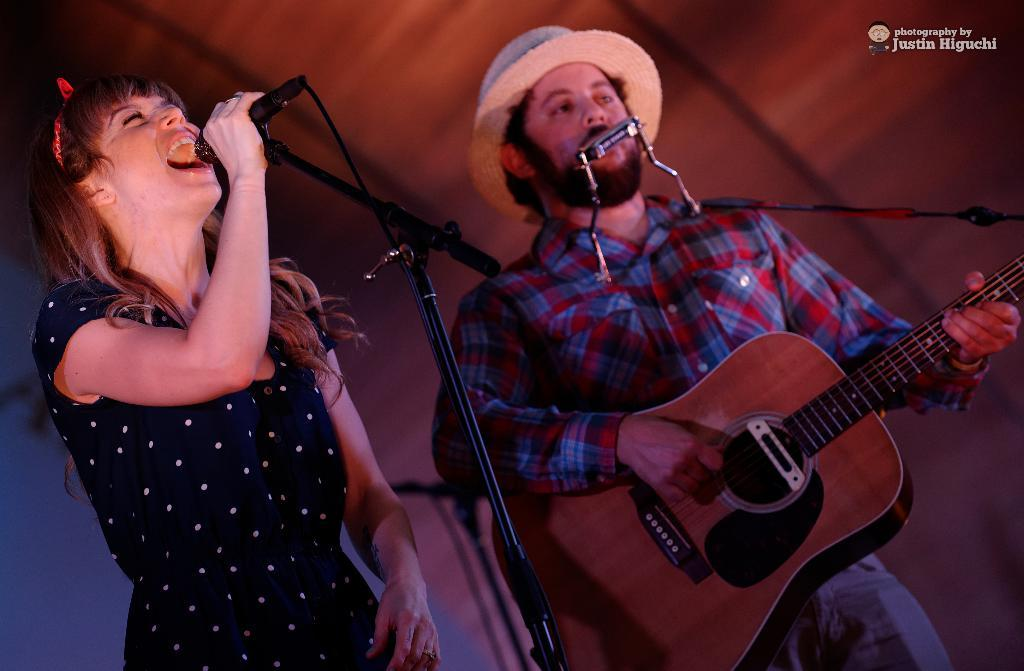How many people are in the image? There are two persons in the image. Where are the two persons located? The two persons are standing on a stage. What are the two persons doing on the stage? The two persons are playing musical instruments. What type of jail can be seen in the background of the image? There is no jail present in the image; it features two persons playing musical instruments on a stage. 